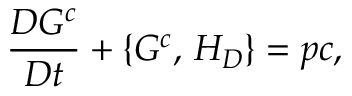Convert formula to latex. <formula><loc_0><loc_0><loc_500><loc_500>\frac { D G ^ { c } } { D t } + \{ G ^ { c } , \, H _ { D } \} = p c ,</formula> 